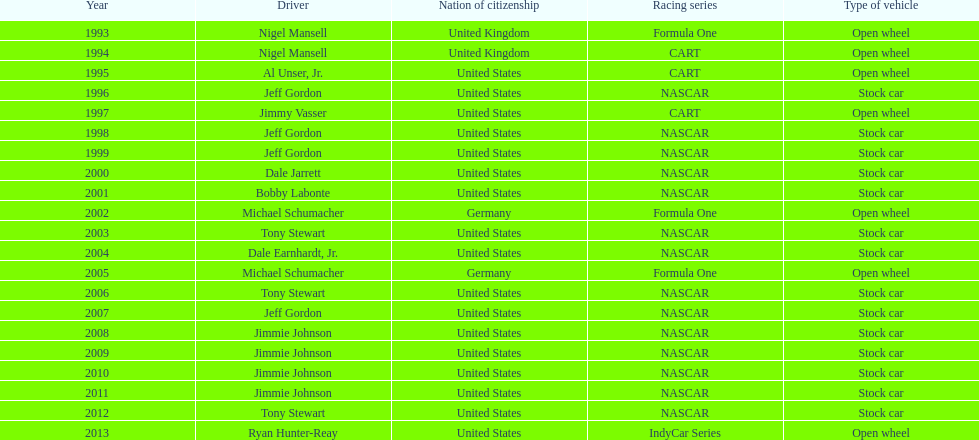Which driver had four consecutive wins? Jimmie Johnson. Can you give me this table as a dict? {'header': ['Year', 'Driver', 'Nation of citizenship', 'Racing series', 'Type of vehicle'], 'rows': [['1993', 'Nigel Mansell', 'United Kingdom', 'Formula One', 'Open wheel'], ['1994', 'Nigel Mansell', 'United Kingdom', 'CART', 'Open wheel'], ['1995', 'Al Unser, Jr.', 'United States', 'CART', 'Open wheel'], ['1996', 'Jeff Gordon', 'United States', 'NASCAR', 'Stock car'], ['1997', 'Jimmy Vasser', 'United States', 'CART', 'Open wheel'], ['1998', 'Jeff Gordon', 'United States', 'NASCAR', 'Stock car'], ['1999', 'Jeff Gordon', 'United States', 'NASCAR', 'Stock car'], ['2000', 'Dale Jarrett', 'United States', 'NASCAR', 'Stock car'], ['2001', 'Bobby Labonte', 'United States', 'NASCAR', 'Stock car'], ['2002', 'Michael Schumacher', 'Germany', 'Formula One', 'Open wheel'], ['2003', 'Tony Stewart', 'United States', 'NASCAR', 'Stock car'], ['2004', 'Dale Earnhardt, Jr.', 'United States', 'NASCAR', 'Stock car'], ['2005', 'Michael Schumacher', 'Germany', 'Formula One', 'Open wheel'], ['2006', 'Tony Stewart', 'United States', 'NASCAR', 'Stock car'], ['2007', 'Jeff Gordon', 'United States', 'NASCAR', 'Stock car'], ['2008', 'Jimmie Johnson', 'United States', 'NASCAR', 'Stock car'], ['2009', 'Jimmie Johnson', 'United States', 'NASCAR', 'Stock car'], ['2010', 'Jimmie Johnson', 'United States', 'NASCAR', 'Stock car'], ['2011', 'Jimmie Johnson', 'United States', 'NASCAR', 'Stock car'], ['2012', 'Tony Stewart', 'United States', 'NASCAR', 'Stock car'], ['2013', 'Ryan Hunter-Reay', 'United States', 'IndyCar Series', 'Open wheel']]} 